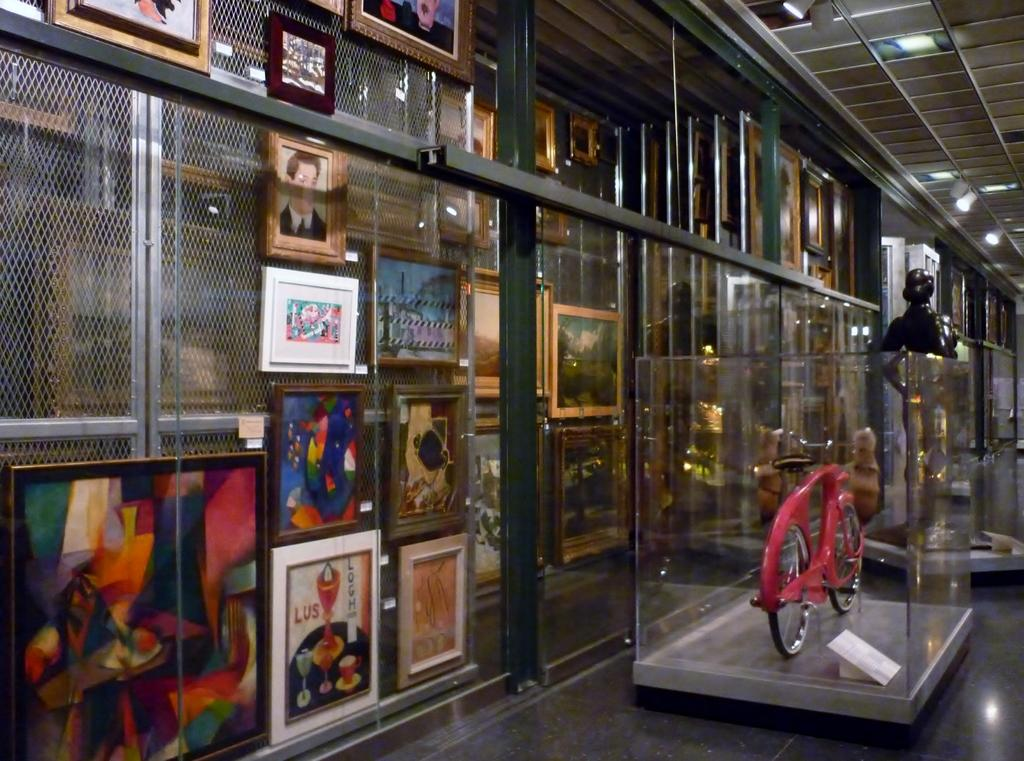What is the main object in the image? There is a cycle in the image. Where is the cycle located? The cycle is inside a museum. What other objects can be seen in the image? There are wooden photo frames in the image. How are the wooden photo frames positioned in the image? The wooden photo frames are hung on a metal wall. What is the condition of the person's lip in the image? There is no person or lip visible in the image; it only features a cycle, wooden photo frames, and a metal wall. 